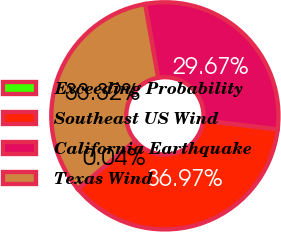Convert chart. <chart><loc_0><loc_0><loc_500><loc_500><pie_chart><fcel>Exceeding Probability<fcel>Southeast US Wind<fcel>California Earthquake<fcel>Texas Wind<nl><fcel>0.04%<fcel>36.97%<fcel>29.67%<fcel>33.32%<nl></chart> 